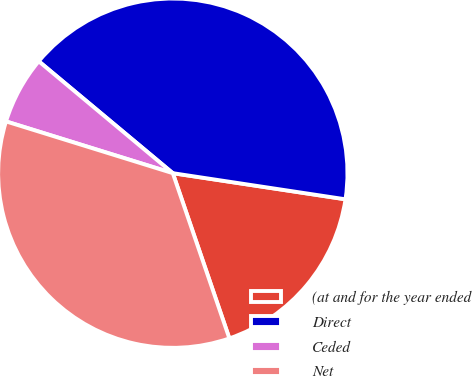<chart> <loc_0><loc_0><loc_500><loc_500><pie_chart><fcel>(at and for the year ended<fcel>Direct<fcel>Ceded<fcel>Net<nl><fcel>17.36%<fcel>41.32%<fcel>6.28%<fcel>35.04%<nl></chart> 